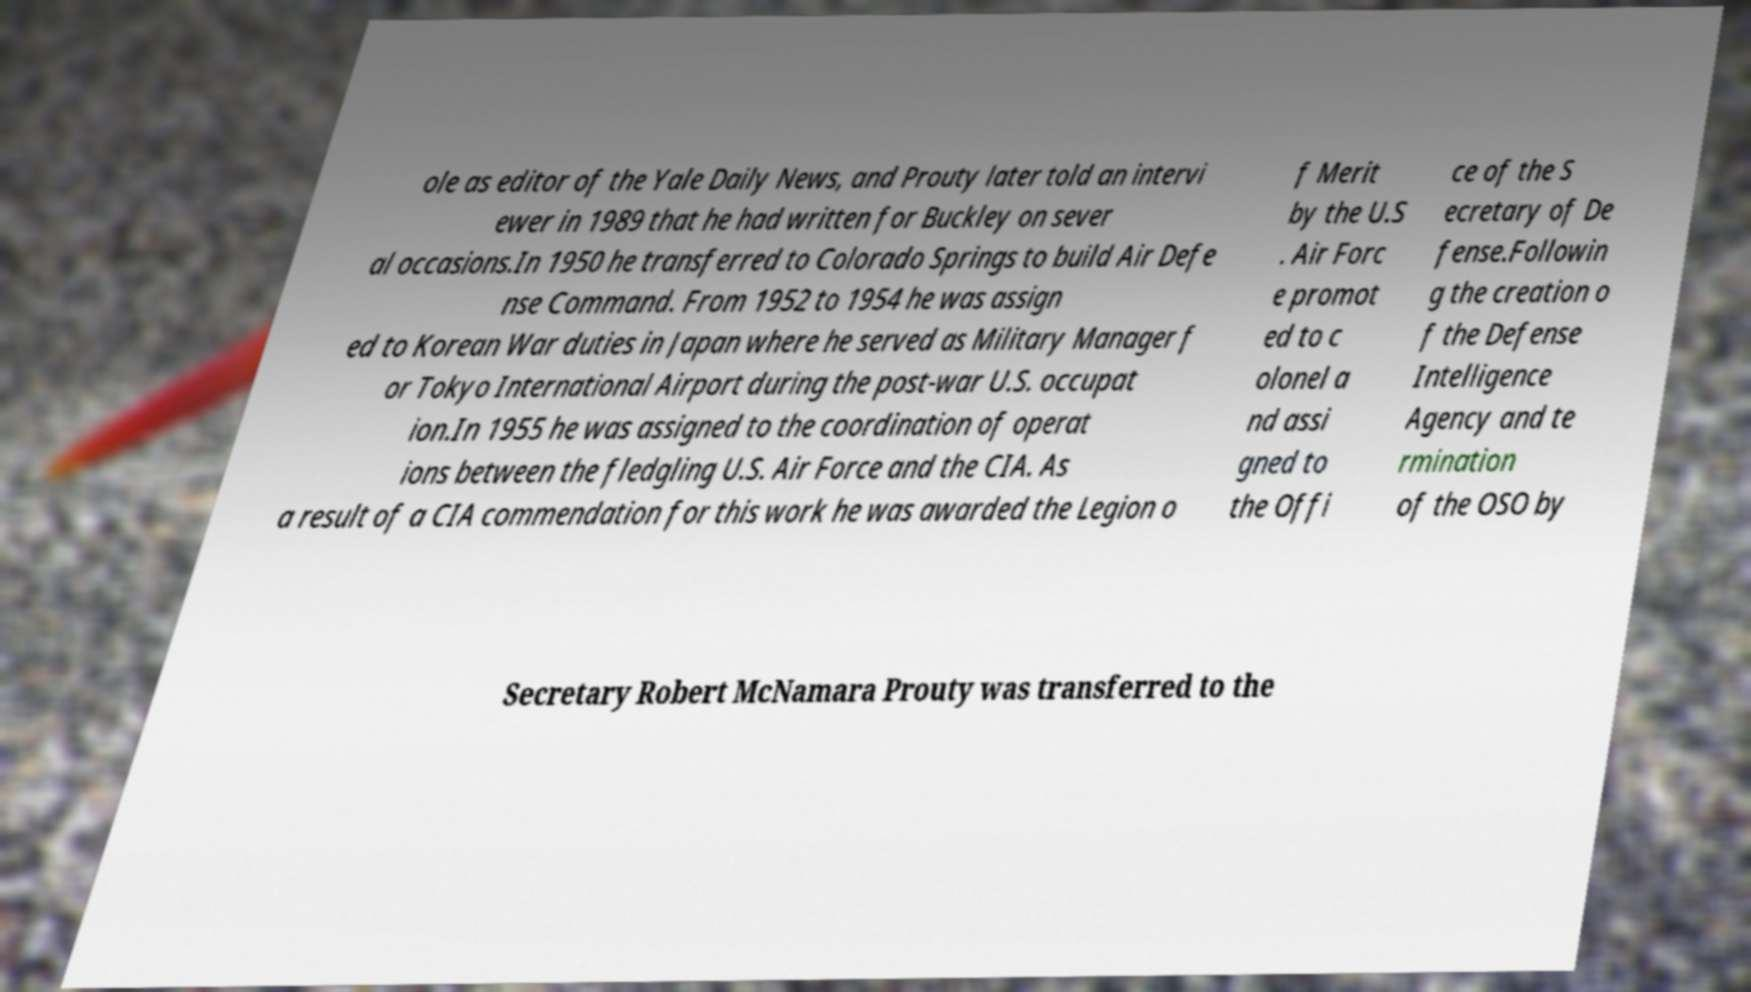Can you read and provide the text displayed in the image?This photo seems to have some interesting text. Can you extract and type it out for me? ole as editor of the Yale Daily News, and Prouty later told an intervi ewer in 1989 that he had written for Buckley on sever al occasions.In 1950 he transferred to Colorado Springs to build Air Defe nse Command. From 1952 to 1954 he was assign ed to Korean War duties in Japan where he served as Military Manager f or Tokyo International Airport during the post-war U.S. occupat ion.In 1955 he was assigned to the coordination of operat ions between the fledgling U.S. Air Force and the CIA. As a result of a CIA commendation for this work he was awarded the Legion o f Merit by the U.S . Air Forc e promot ed to c olonel a nd assi gned to the Offi ce of the S ecretary of De fense.Followin g the creation o f the Defense Intelligence Agency and te rmination of the OSO by Secretary Robert McNamara Prouty was transferred to the 